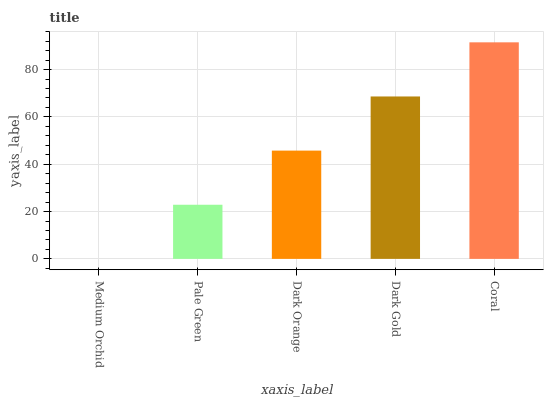Is Medium Orchid the minimum?
Answer yes or no. Yes. Is Coral the maximum?
Answer yes or no. Yes. Is Pale Green the minimum?
Answer yes or no. No. Is Pale Green the maximum?
Answer yes or no. No. Is Pale Green greater than Medium Orchid?
Answer yes or no. Yes. Is Medium Orchid less than Pale Green?
Answer yes or no. Yes. Is Medium Orchid greater than Pale Green?
Answer yes or no. No. Is Pale Green less than Medium Orchid?
Answer yes or no. No. Is Dark Orange the high median?
Answer yes or no. Yes. Is Dark Orange the low median?
Answer yes or no. Yes. Is Dark Gold the high median?
Answer yes or no. No. Is Pale Green the low median?
Answer yes or no. No. 